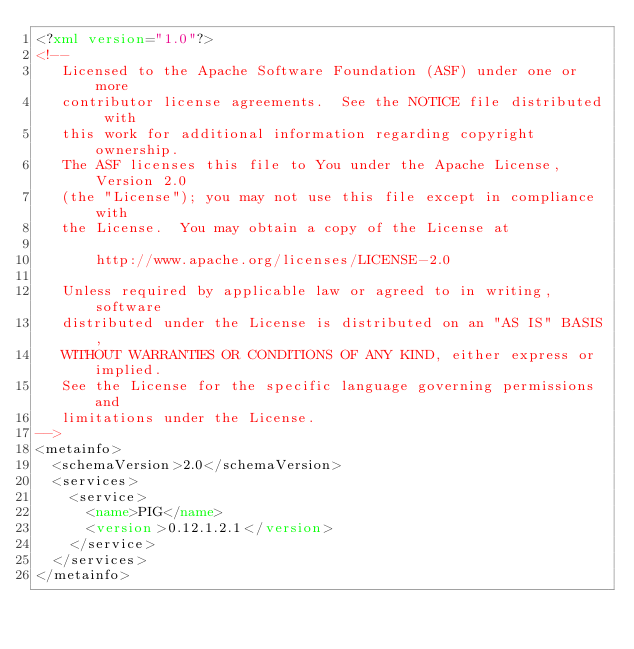<code> <loc_0><loc_0><loc_500><loc_500><_XML_><?xml version="1.0"?>
<!--
   Licensed to the Apache Software Foundation (ASF) under one or more
   contributor license agreements.  See the NOTICE file distributed with
   this work for additional information regarding copyright ownership.
   The ASF licenses this file to You under the Apache License, Version 2.0
   (the "License"); you may not use this file except in compliance with
   the License.  You may obtain a copy of the License at

       http://www.apache.org/licenses/LICENSE-2.0

   Unless required by applicable law or agreed to in writing, software
   distributed under the License is distributed on an "AS IS" BASIS,
   WITHOUT WARRANTIES OR CONDITIONS OF ANY KIND, either express or implied.
   See the License for the specific language governing permissions and
   limitations under the License.
-->
<metainfo>
  <schemaVersion>2.0</schemaVersion>
  <services>
    <service>
      <name>PIG</name>
      <version>0.12.1.2.1</version>
    </service>
  </services>
</metainfo>
</code> 